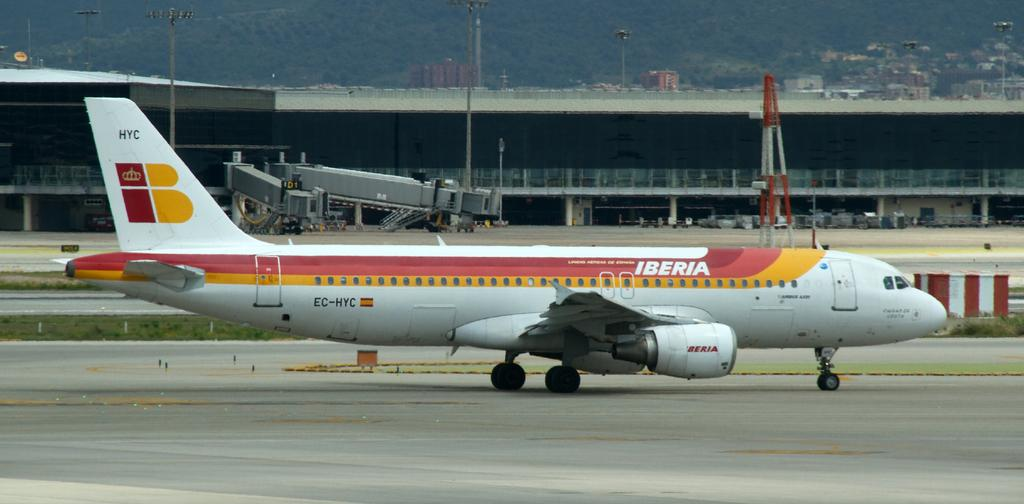What is the main subject in the front of the image? There is an airplane in the front of the image. What type of vegetation can be seen on the right side of the image? There is grass on the right side of the image. What can be seen in the background of the image? There are buildings, poles, and trees in the background of the image. What is located in the middle of the image? There is a railing in the middle of the image. Where is the baby resting on the rock in the image? There is no baby or rock present in the image. 